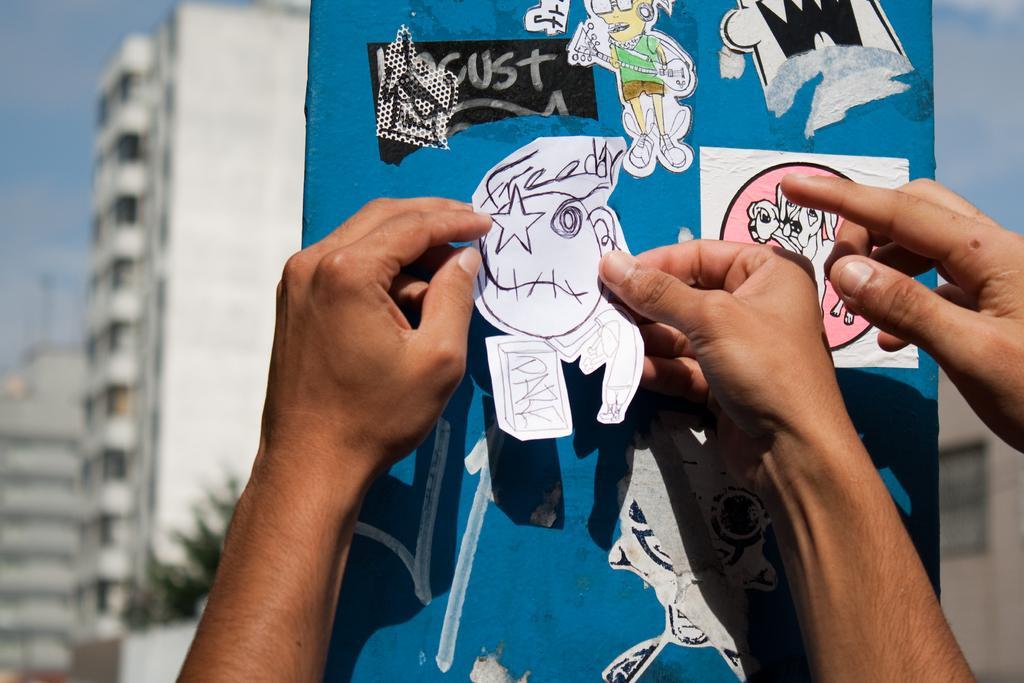In one or two sentences, can you explain what this image depicts? In this picture we can see some persons hands, stickers and in the background we can see trees, buildings, sky with clouds and it is blurry. 